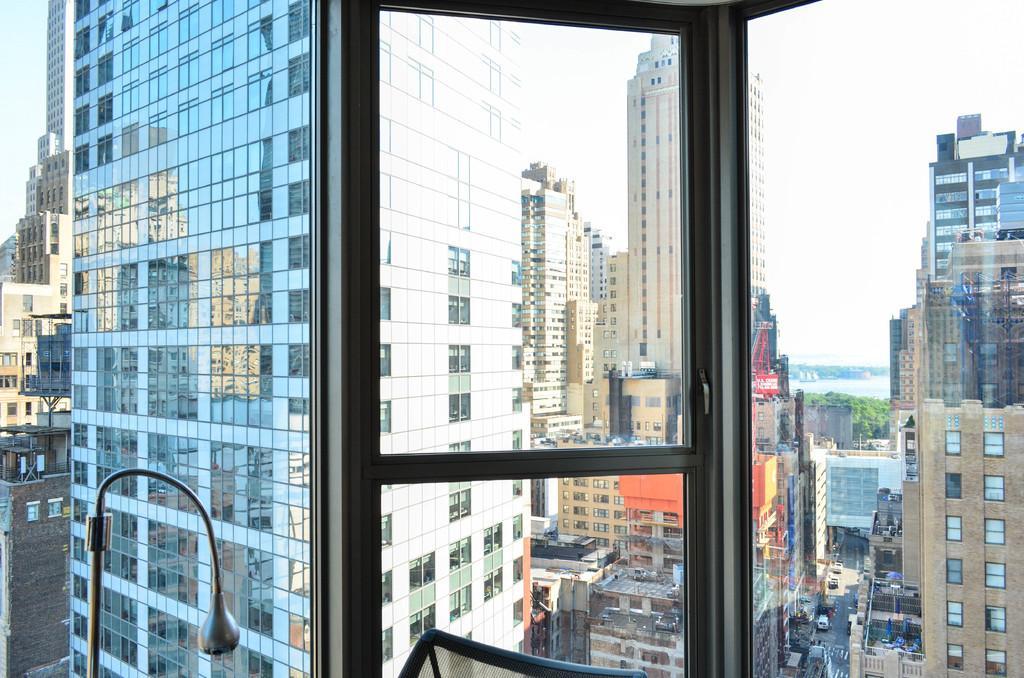How would you summarize this image in a sentence or two? In this image I can see a glass. In the middle of the image there is a glass door through which we can see the outside view. On the left side there is a metal stand. In the outside there are many buildings, trees. At the bottom there are few vehicles on a road. At the top of the image I can see the sky. 